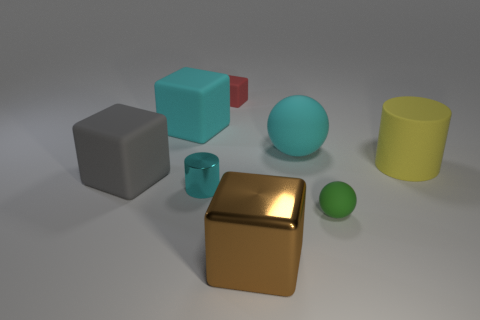Add 1 large cyan balls. How many objects exist? 9 Subtract all red blocks. How many blocks are left? 3 Subtract 0 red cylinders. How many objects are left? 8 Subtract all cylinders. How many objects are left? 6 Subtract 2 cubes. How many cubes are left? 2 Subtract all blue cylinders. Subtract all yellow cubes. How many cylinders are left? 2 Subtract all blue blocks. How many cyan spheres are left? 1 Subtract all matte things. Subtract all tiny metal objects. How many objects are left? 1 Add 2 rubber spheres. How many rubber spheres are left? 4 Add 8 tiny green matte spheres. How many tiny green matte spheres exist? 9 